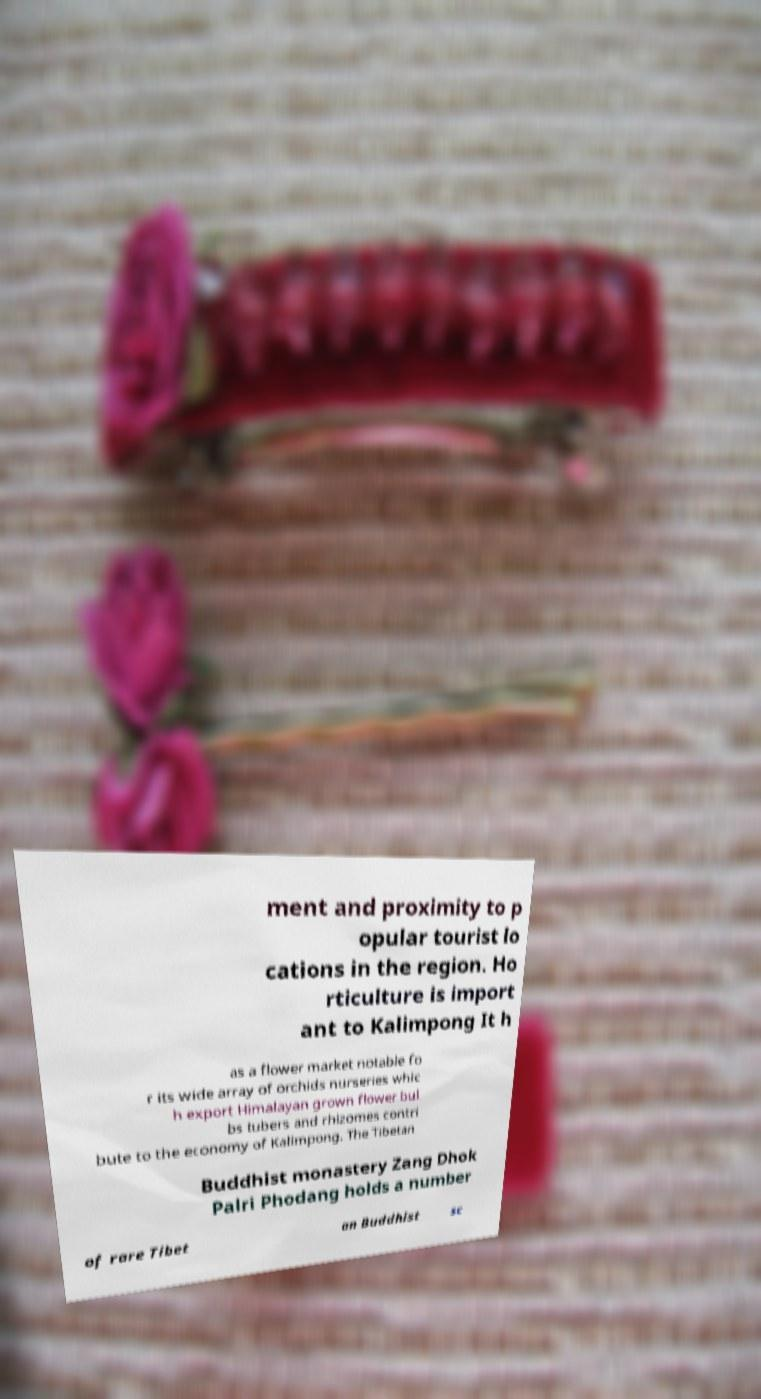What messages or text are displayed in this image? I need them in a readable, typed format. ment and proximity to p opular tourist lo cations in the region. Ho rticulture is import ant to Kalimpong It h as a flower market notable fo r its wide array of orchids nurseries whic h export Himalayan grown flower bul bs tubers and rhizomes contri bute to the economy of Kalimpong. The Tibetan Buddhist monastery Zang Dhok Palri Phodang holds a number of rare Tibet an Buddhist sc 